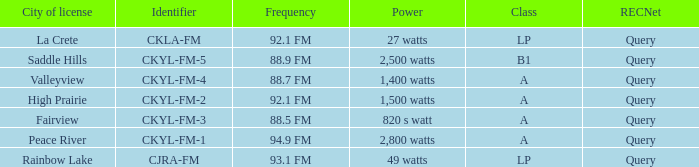What is the city of license that has a 1,400 watts power Valleyview. 